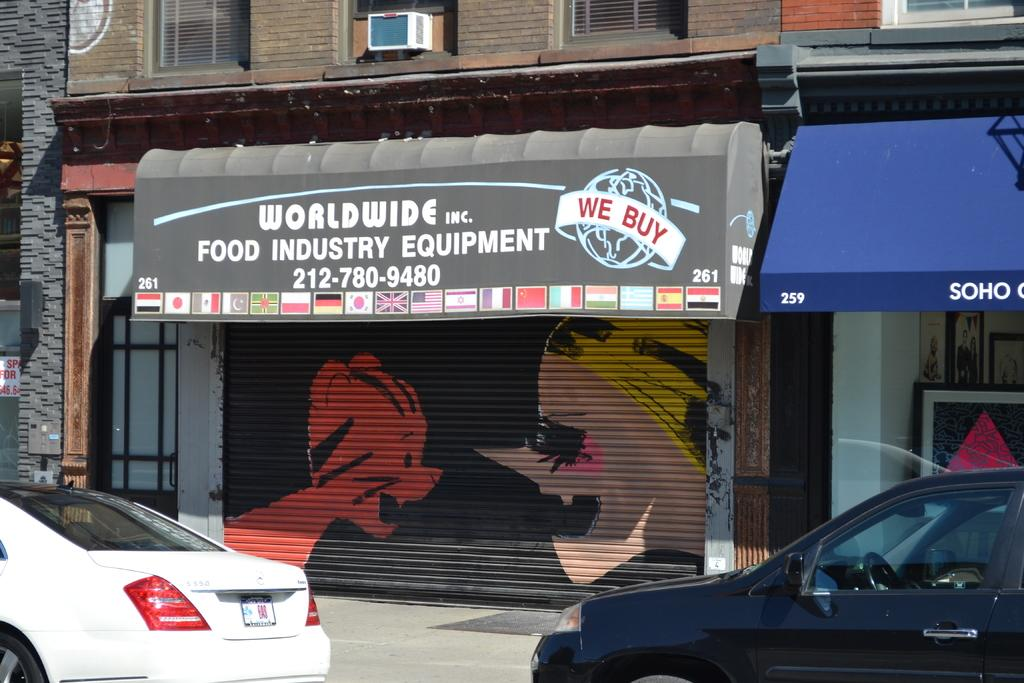What can be seen on the road in the image? There are cars parked on the road in the image. What is visible in the background of the image? There is a building and shutters visible in the background of the image. What else can be seen in the background of the image? There are boards visible in the background of the image. How far away is the butter from the cars in the image? There is no butter present in the image, so it cannot be determined how far away it might be from the cars. 